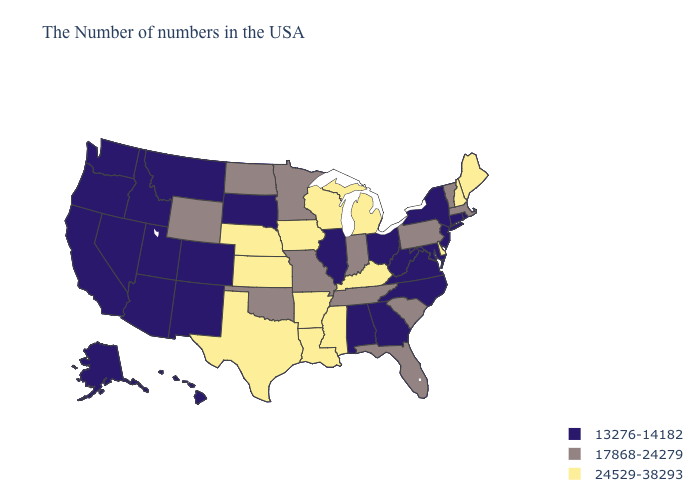Name the states that have a value in the range 17868-24279?
Be succinct. Massachusetts, Vermont, Pennsylvania, South Carolina, Florida, Indiana, Tennessee, Missouri, Minnesota, Oklahoma, North Dakota, Wyoming. What is the value of Connecticut?
Answer briefly. 13276-14182. What is the highest value in states that border Louisiana?
Quick response, please. 24529-38293. What is the value of Indiana?
Be succinct. 17868-24279. What is the highest value in states that border Rhode Island?
Be succinct. 17868-24279. What is the value of New York?
Write a very short answer. 13276-14182. Does the first symbol in the legend represent the smallest category?
Write a very short answer. Yes. Does Iowa have a higher value than South Carolina?
Concise answer only. Yes. Name the states that have a value in the range 13276-14182?
Give a very brief answer. Rhode Island, Connecticut, New York, New Jersey, Maryland, Virginia, North Carolina, West Virginia, Ohio, Georgia, Alabama, Illinois, South Dakota, Colorado, New Mexico, Utah, Montana, Arizona, Idaho, Nevada, California, Washington, Oregon, Alaska, Hawaii. Which states hav the highest value in the West?
Be succinct. Wyoming. What is the lowest value in states that border New Hampshire?
Answer briefly. 17868-24279. Name the states that have a value in the range 17868-24279?
Give a very brief answer. Massachusetts, Vermont, Pennsylvania, South Carolina, Florida, Indiana, Tennessee, Missouri, Minnesota, Oklahoma, North Dakota, Wyoming. What is the value of Rhode Island?
Keep it brief. 13276-14182. How many symbols are there in the legend?
Write a very short answer. 3. Name the states that have a value in the range 13276-14182?
Keep it brief. Rhode Island, Connecticut, New York, New Jersey, Maryland, Virginia, North Carolina, West Virginia, Ohio, Georgia, Alabama, Illinois, South Dakota, Colorado, New Mexico, Utah, Montana, Arizona, Idaho, Nevada, California, Washington, Oregon, Alaska, Hawaii. 